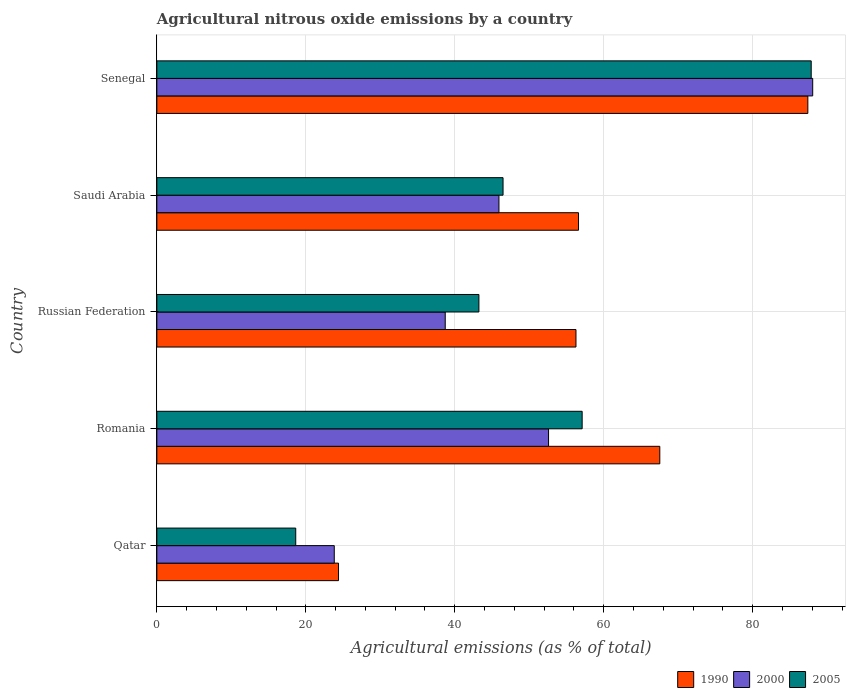How many groups of bars are there?
Offer a very short reply. 5. How many bars are there on the 4th tick from the top?
Your answer should be compact. 3. What is the label of the 2nd group of bars from the top?
Your response must be concise. Saudi Arabia. What is the amount of agricultural nitrous oxide emitted in 1990 in Senegal?
Ensure brevity in your answer.  87.4. Across all countries, what is the maximum amount of agricultural nitrous oxide emitted in 2000?
Provide a short and direct response. 88.05. Across all countries, what is the minimum amount of agricultural nitrous oxide emitted in 2000?
Provide a succinct answer. 23.82. In which country was the amount of agricultural nitrous oxide emitted in 2000 maximum?
Your response must be concise. Senegal. In which country was the amount of agricultural nitrous oxide emitted in 2005 minimum?
Keep it short and to the point. Qatar. What is the total amount of agricultural nitrous oxide emitted in 2005 in the graph?
Your answer should be compact. 253.32. What is the difference between the amount of agricultural nitrous oxide emitted in 2000 in Qatar and that in Russian Federation?
Ensure brevity in your answer.  -14.9. What is the difference between the amount of agricultural nitrous oxide emitted in 2005 in Saudi Arabia and the amount of agricultural nitrous oxide emitted in 2000 in Senegal?
Keep it short and to the point. -41.57. What is the average amount of agricultural nitrous oxide emitted in 1990 per country?
Offer a terse response. 58.44. What is the difference between the amount of agricultural nitrous oxide emitted in 2000 and amount of agricultural nitrous oxide emitted in 1990 in Qatar?
Ensure brevity in your answer.  -0.57. In how many countries, is the amount of agricultural nitrous oxide emitted in 2000 greater than 80 %?
Your answer should be compact. 1. What is the ratio of the amount of agricultural nitrous oxide emitted in 2005 in Qatar to that in Russian Federation?
Your answer should be compact. 0.43. What is the difference between the highest and the second highest amount of agricultural nitrous oxide emitted in 1990?
Provide a short and direct response. 19.88. What is the difference between the highest and the lowest amount of agricultural nitrous oxide emitted in 1990?
Ensure brevity in your answer.  63.01. What does the 2nd bar from the top in Saudi Arabia represents?
Your answer should be very brief. 2000. Is it the case that in every country, the sum of the amount of agricultural nitrous oxide emitted in 2000 and amount of agricultural nitrous oxide emitted in 2005 is greater than the amount of agricultural nitrous oxide emitted in 1990?
Provide a short and direct response. Yes. Are all the bars in the graph horizontal?
Your answer should be compact. Yes. How many countries are there in the graph?
Your answer should be compact. 5. Are the values on the major ticks of X-axis written in scientific E-notation?
Give a very brief answer. No. Does the graph contain grids?
Offer a terse response. Yes. Where does the legend appear in the graph?
Provide a succinct answer. Bottom right. What is the title of the graph?
Your answer should be compact. Agricultural nitrous oxide emissions by a country. What is the label or title of the X-axis?
Make the answer very short. Agricultural emissions (as % of total). What is the label or title of the Y-axis?
Keep it short and to the point. Country. What is the Agricultural emissions (as % of total) of 1990 in Qatar?
Your response must be concise. 24.39. What is the Agricultural emissions (as % of total) in 2000 in Qatar?
Ensure brevity in your answer.  23.82. What is the Agricultural emissions (as % of total) in 2005 in Qatar?
Make the answer very short. 18.65. What is the Agricultural emissions (as % of total) in 1990 in Romania?
Your answer should be very brief. 67.52. What is the Agricultural emissions (as % of total) of 2000 in Romania?
Keep it short and to the point. 52.59. What is the Agricultural emissions (as % of total) of 2005 in Romania?
Your answer should be compact. 57.1. What is the Agricultural emissions (as % of total) in 1990 in Russian Federation?
Give a very brief answer. 56.27. What is the Agricultural emissions (as % of total) of 2000 in Russian Federation?
Your answer should be very brief. 38.72. What is the Agricultural emissions (as % of total) of 2005 in Russian Federation?
Give a very brief answer. 43.24. What is the Agricultural emissions (as % of total) of 1990 in Saudi Arabia?
Your response must be concise. 56.61. What is the Agricultural emissions (as % of total) in 2000 in Saudi Arabia?
Keep it short and to the point. 45.93. What is the Agricultural emissions (as % of total) of 2005 in Saudi Arabia?
Your response must be concise. 46.48. What is the Agricultural emissions (as % of total) of 1990 in Senegal?
Your response must be concise. 87.4. What is the Agricultural emissions (as % of total) in 2000 in Senegal?
Make the answer very short. 88.05. What is the Agricultural emissions (as % of total) in 2005 in Senegal?
Provide a succinct answer. 87.85. Across all countries, what is the maximum Agricultural emissions (as % of total) of 1990?
Keep it short and to the point. 87.4. Across all countries, what is the maximum Agricultural emissions (as % of total) of 2000?
Keep it short and to the point. 88.05. Across all countries, what is the maximum Agricultural emissions (as % of total) in 2005?
Give a very brief answer. 87.85. Across all countries, what is the minimum Agricultural emissions (as % of total) in 1990?
Offer a terse response. 24.39. Across all countries, what is the minimum Agricultural emissions (as % of total) of 2000?
Give a very brief answer. 23.82. Across all countries, what is the minimum Agricultural emissions (as % of total) in 2005?
Provide a succinct answer. 18.65. What is the total Agricultural emissions (as % of total) in 1990 in the graph?
Offer a terse response. 292.2. What is the total Agricultural emissions (as % of total) in 2000 in the graph?
Keep it short and to the point. 249.11. What is the total Agricultural emissions (as % of total) of 2005 in the graph?
Your answer should be very brief. 253.32. What is the difference between the Agricultural emissions (as % of total) of 1990 in Qatar and that in Romania?
Provide a short and direct response. -43.13. What is the difference between the Agricultural emissions (as % of total) of 2000 in Qatar and that in Romania?
Your answer should be compact. -28.77. What is the difference between the Agricultural emissions (as % of total) of 2005 in Qatar and that in Romania?
Offer a terse response. -38.45. What is the difference between the Agricultural emissions (as % of total) in 1990 in Qatar and that in Russian Federation?
Your answer should be very brief. -31.88. What is the difference between the Agricultural emissions (as % of total) in 2000 in Qatar and that in Russian Federation?
Provide a succinct answer. -14.9. What is the difference between the Agricultural emissions (as % of total) in 2005 in Qatar and that in Russian Federation?
Make the answer very short. -24.59. What is the difference between the Agricultural emissions (as % of total) of 1990 in Qatar and that in Saudi Arabia?
Keep it short and to the point. -32.22. What is the difference between the Agricultural emissions (as % of total) in 2000 in Qatar and that in Saudi Arabia?
Ensure brevity in your answer.  -22.11. What is the difference between the Agricultural emissions (as % of total) of 2005 in Qatar and that in Saudi Arabia?
Your response must be concise. -27.83. What is the difference between the Agricultural emissions (as % of total) of 1990 in Qatar and that in Senegal?
Ensure brevity in your answer.  -63.01. What is the difference between the Agricultural emissions (as % of total) of 2000 in Qatar and that in Senegal?
Provide a short and direct response. -64.23. What is the difference between the Agricultural emissions (as % of total) in 2005 in Qatar and that in Senegal?
Provide a short and direct response. -69.2. What is the difference between the Agricultural emissions (as % of total) in 1990 in Romania and that in Russian Federation?
Offer a terse response. 11.25. What is the difference between the Agricultural emissions (as % of total) of 2000 in Romania and that in Russian Federation?
Offer a very short reply. 13.87. What is the difference between the Agricultural emissions (as % of total) of 2005 in Romania and that in Russian Federation?
Keep it short and to the point. 13.86. What is the difference between the Agricultural emissions (as % of total) in 1990 in Romania and that in Saudi Arabia?
Ensure brevity in your answer.  10.91. What is the difference between the Agricultural emissions (as % of total) in 2000 in Romania and that in Saudi Arabia?
Give a very brief answer. 6.66. What is the difference between the Agricultural emissions (as % of total) of 2005 in Romania and that in Saudi Arabia?
Give a very brief answer. 10.62. What is the difference between the Agricultural emissions (as % of total) of 1990 in Romania and that in Senegal?
Provide a short and direct response. -19.88. What is the difference between the Agricultural emissions (as % of total) in 2000 in Romania and that in Senegal?
Provide a short and direct response. -35.47. What is the difference between the Agricultural emissions (as % of total) in 2005 in Romania and that in Senegal?
Offer a very short reply. -30.75. What is the difference between the Agricultural emissions (as % of total) in 1990 in Russian Federation and that in Saudi Arabia?
Provide a short and direct response. -0.34. What is the difference between the Agricultural emissions (as % of total) of 2000 in Russian Federation and that in Saudi Arabia?
Offer a very short reply. -7.21. What is the difference between the Agricultural emissions (as % of total) of 2005 in Russian Federation and that in Saudi Arabia?
Offer a terse response. -3.24. What is the difference between the Agricultural emissions (as % of total) of 1990 in Russian Federation and that in Senegal?
Keep it short and to the point. -31.13. What is the difference between the Agricultural emissions (as % of total) of 2000 in Russian Federation and that in Senegal?
Offer a very short reply. -49.34. What is the difference between the Agricultural emissions (as % of total) in 2005 in Russian Federation and that in Senegal?
Make the answer very short. -44.61. What is the difference between the Agricultural emissions (as % of total) in 1990 in Saudi Arabia and that in Senegal?
Your response must be concise. -30.79. What is the difference between the Agricultural emissions (as % of total) in 2000 in Saudi Arabia and that in Senegal?
Ensure brevity in your answer.  -42.12. What is the difference between the Agricultural emissions (as % of total) of 2005 in Saudi Arabia and that in Senegal?
Keep it short and to the point. -41.37. What is the difference between the Agricultural emissions (as % of total) in 1990 in Qatar and the Agricultural emissions (as % of total) in 2000 in Romania?
Provide a succinct answer. -28.2. What is the difference between the Agricultural emissions (as % of total) in 1990 in Qatar and the Agricultural emissions (as % of total) in 2005 in Romania?
Your response must be concise. -32.71. What is the difference between the Agricultural emissions (as % of total) of 2000 in Qatar and the Agricultural emissions (as % of total) of 2005 in Romania?
Your response must be concise. -33.28. What is the difference between the Agricultural emissions (as % of total) in 1990 in Qatar and the Agricultural emissions (as % of total) in 2000 in Russian Federation?
Make the answer very short. -14.33. What is the difference between the Agricultural emissions (as % of total) of 1990 in Qatar and the Agricultural emissions (as % of total) of 2005 in Russian Federation?
Make the answer very short. -18.85. What is the difference between the Agricultural emissions (as % of total) in 2000 in Qatar and the Agricultural emissions (as % of total) in 2005 in Russian Federation?
Ensure brevity in your answer.  -19.42. What is the difference between the Agricultural emissions (as % of total) in 1990 in Qatar and the Agricultural emissions (as % of total) in 2000 in Saudi Arabia?
Offer a terse response. -21.54. What is the difference between the Agricultural emissions (as % of total) of 1990 in Qatar and the Agricultural emissions (as % of total) of 2005 in Saudi Arabia?
Make the answer very short. -22.09. What is the difference between the Agricultural emissions (as % of total) in 2000 in Qatar and the Agricultural emissions (as % of total) in 2005 in Saudi Arabia?
Make the answer very short. -22.66. What is the difference between the Agricultural emissions (as % of total) of 1990 in Qatar and the Agricultural emissions (as % of total) of 2000 in Senegal?
Ensure brevity in your answer.  -63.66. What is the difference between the Agricultural emissions (as % of total) in 1990 in Qatar and the Agricultural emissions (as % of total) in 2005 in Senegal?
Make the answer very short. -63.46. What is the difference between the Agricultural emissions (as % of total) of 2000 in Qatar and the Agricultural emissions (as % of total) of 2005 in Senegal?
Offer a very short reply. -64.03. What is the difference between the Agricultural emissions (as % of total) of 1990 in Romania and the Agricultural emissions (as % of total) of 2000 in Russian Federation?
Provide a short and direct response. 28.81. What is the difference between the Agricultural emissions (as % of total) of 1990 in Romania and the Agricultural emissions (as % of total) of 2005 in Russian Federation?
Provide a succinct answer. 24.28. What is the difference between the Agricultural emissions (as % of total) in 2000 in Romania and the Agricultural emissions (as % of total) in 2005 in Russian Federation?
Make the answer very short. 9.35. What is the difference between the Agricultural emissions (as % of total) in 1990 in Romania and the Agricultural emissions (as % of total) in 2000 in Saudi Arabia?
Ensure brevity in your answer.  21.59. What is the difference between the Agricultural emissions (as % of total) in 1990 in Romania and the Agricultural emissions (as % of total) in 2005 in Saudi Arabia?
Your answer should be very brief. 21.04. What is the difference between the Agricultural emissions (as % of total) of 2000 in Romania and the Agricultural emissions (as % of total) of 2005 in Saudi Arabia?
Your answer should be very brief. 6.11. What is the difference between the Agricultural emissions (as % of total) in 1990 in Romania and the Agricultural emissions (as % of total) in 2000 in Senegal?
Your response must be concise. -20.53. What is the difference between the Agricultural emissions (as % of total) of 1990 in Romania and the Agricultural emissions (as % of total) of 2005 in Senegal?
Offer a terse response. -20.33. What is the difference between the Agricultural emissions (as % of total) of 2000 in Romania and the Agricultural emissions (as % of total) of 2005 in Senegal?
Make the answer very short. -35.26. What is the difference between the Agricultural emissions (as % of total) of 1990 in Russian Federation and the Agricultural emissions (as % of total) of 2000 in Saudi Arabia?
Provide a succinct answer. 10.34. What is the difference between the Agricultural emissions (as % of total) of 1990 in Russian Federation and the Agricultural emissions (as % of total) of 2005 in Saudi Arabia?
Your response must be concise. 9.79. What is the difference between the Agricultural emissions (as % of total) in 2000 in Russian Federation and the Agricultural emissions (as % of total) in 2005 in Saudi Arabia?
Provide a short and direct response. -7.76. What is the difference between the Agricultural emissions (as % of total) in 1990 in Russian Federation and the Agricultural emissions (as % of total) in 2000 in Senegal?
Make the answer very short. -31.78. What is the difference between the Agricultural emissions (as % of total) of 1990 in Russian Federation and the Agricultural emissions (as % of total) of 2005 in Senegal?
Offer a terse response. -31.58. What is the difference between the Agricultural emissions (as % of total) in 2000 in Russian Federation and the Agricultural emissions (as % of total) in 2005 in Senegal?
Ensure brevity in your answer.  -49.13. What is the difference between the Agricultural emissions (as % of total) in 1990 in Saudi Arabia and the Agricultural emissions (as % of total) in 2000 in Senegal?
Provide a succinct answer. -31.44. What is the difference between the Agricultural emissions (as % of total) in 1990 in Saudi Arabia and the Agricultural emissions (as % of total) in 2005 in Senegal?
Make the answer very short. -31.24. What is the difference between the Agricultural emissions (as % of total) of 2000 in Saudi Arabia and the Agricultural emissions (as % of total) of 2005 in Senegal?
Your answer should be compact. -41.92. What is the average Agricultural emissions (as % of total) of 1990 per country?
Your response must be concise. 58.44. What is the average Agricultural emissions (as % of total) of 2000 per country?
Offer a terse response. 49.82. What is the average Agricultural emissions (as % of total) of 2005 per country?
Provide a short and direct response. 50.66. What is the difference between the Agricultural emissions (as % of total) in 1990 and Agricultural emissions (as % of total) in 2000 in Qatar?
Your answer should be very brief. 0.57. What is the difference between the Agricultural emissions (as % of total) of 1990 and Agricultural emissions (as % of total) of 2005 in Qatar?
Give a very brief answer. 5.74. What is the difference between the Agricultural emissions (as % of total) of 2000 and Agricultural emissions (as % of total) of 2005 in Qatar?
Your response must be concise. 5.17. What is the difference between the Agricultural emissions (as % of total) of 1990 and Agricultural emissions (as % of total) of 2000 in Romania?
Provide a succinct answer. 14.94. What is the difference between the Agricultural emissions (as % of total) in 1990 and Agricultural emissions (as % of total) in 2005 in Romania?
Your answer should be very brief. 10.42. What is the difference between the Agricultural emissions (as % of total) of 2000 and Agricultural emissions (as % of total) of 2005 in Romania?
Keep it short and to the point. -4.51. What is the difference between the Agricultural emissions (as % of total) of 1990 and Agricultural emissions (as % of total) of 2000 in Russian Federation?
Keep it short and to the point. 17.55. What is the difference between the Agricultural emissions (as % of total) of 1990 and Agricultural emissions (as % of total) of 2005 in Russian Federation?
Provide a succinct answer. 13.03. What is the difference between the Agricultural emissions (as % of total) in 2000 and Agricultural emissions (as % of total) in 2005 in Russian Federation?
Keep it short and to the point. -4.52. What is the difference between the Agricultural emissions (as % of total) in 1990 and Agricultural emissions (as % of total) in 2000 in Saudi Arabia?
Provide a succinct answer. 10.68. What is the difference between the Agricultural emissions (as % of total) in 1990 and Agricultural emissions (as % of total) in 2005 in Saudi Arabia?
Provide a succinct answer. 10.13. What is the difference between the Agricultural emissions (as % of total) in 2000 and Agricultural emissions (as % of total) in 2005 in Saudi Arabia?
Keep it short and to the point. -0.55. What is the difference between the Agricultural emissions (as % of total) of 1990 and Agricultural emissions (as % of total) of 2000 in Senegal?
Your answer should be very brief. -0.65. What is the difference between the Agricultural emissions (as % of total) of 1990 and Agricultural emissions (as % of total) of 2005 in Senegal?
Provide a succinct answer. -0.45. What is the difference between the Agricultural emissions (as % of total) in 2000 and Agricultural emissions (as % of total) in 2005 in Senegal?
Give a very brief answer. 0.2. What is the ratio of the Agricultural emissions (as % of total) of 1990 in Qatar to that in Romania?
Your answer should be compact. 0.36. What is the ratio of the Agricultural emissions (as % of total) in 2000 in Qatar to that in Romania?
Ensure brevity in your answer.  0.45. What is the ratio of the Agricultural emissions (as % of total) in 2005 in Qatar to that in Romania?
Ensure brevity in your answer.  0.33. What is the ratio of the Agricultural emissions (as % of total) of 1990 in Qatar to that in Russian Federation?
Provide a short and direct response. 0.43. What is the ratio of the Agricultural emissions (as % of total) of 2000 in Qatar to that in Russian Federation?
Offer a terse response. 0.62. What is the ratio of the Agricultural emissions (as % of total) in 2005 in Qatar to that in Russian Federation?
Offer a very short reply. 0.43. What is the ratio of the Agricultural emissions (as % of total) in 1990 in Qatar to that in Saudi Arabia?
Ensure brevity in your answer.  0.43. What is the ratio of the Agricultural emissions (as % of total) of 2000 in Qatar to that in Saudi Arabia?
Offer a very short reply. 0.52. What is the ratio of the Agricultural emissions (as % of total) in 2005 in Qatar to that in Saudi Arabia?
Offer a very short reply. 0.4. What is the ratio of the Agricultural emissions (as % of total) in 1990 in Qatar to that in Senegal?
Provide a succinct answer. 0.28. What is the ratio of the Agricultural emissions (as % of total) in 2000 in Qatar to that in Senegal?
Ensure brevity in your answer.  0.27. What is the ratio of the Agricultural emissions (as % of total) in 2005 in Qatar to that in Senegal?
Provide a succinct answer. 0.21. What is the ratio of the Agricultural emissions (as % of total) in 1990 in Romania to that in Russian Federation?
Offer a very short reply. 1.2. What is the ratio of the Agricultural emissions (as % of total) of 2000 in Romania to that in Russian Federation?
Offer a terse response. 1.36. What is the ratio of the Agricultural emissions (as % of total) of 2005 in Romania to that in Russian Federation?
Provide a succinct answer. 1.32. What is the ratio of the Agricultural emissions (as % of total) of 1990 in Romania to that in Saudi Arabia?
Your response must be concise. 1.19. What is the ratio of the Agricultural emissions (as % of total) of 2000 in Romania to that in Saudi Arabia?
Your answer should be compact. 1.15. What is the ratio of the Agricultural emissions (as % of total) in 2005 in Romania to that in Saudi Arabia?
Offer a very short reply. 1.23. What is the ratio of the Agricultural emissions (as % of total) in 1990 in Romania to that in Senegal?
Your answer should be compact. 0.77. What is the ratio of the Agricultural emissions (as % of total) of 2000 in Romania to that in Senegal?
Keep it short and to the point. 0.6. What is the ratio of the Agricultural emissions (as % of total) in 2005 in Romania to that in Senegal?
Offer a very short reply. 0.65. What is the ratio of the Agricultural emissions (as % of total) in 2000 in Russian Federation to that in Saudi Arabia?
Offer a terse response. 0.84. What is the ratio of the Agricultural emissions (as % of total) of 2005 in Russian Federation to that in Saudi Arabia?
Ensure brevity in your answer.  0.93. What is the ratio of the Agricultural emissions (as % of total) of 1990 in Russian Federation to that in Senegal?
Provide a short and direct response. 0.64. What is the ratio of the Agricultural emissions (as % of total) of 2000 in Russian Federation to that in Senegal?
Offer a terse response. 0.44. What is the ratio of the Agricultural emissions (as % of total) in 2005 in Russian Federation to that in Senegal?
Provide a short and direct response. 0.49. What is the ratio of the Agricultural emissions (as % of total) in 1990 in Saudi Arabia to that in Senegal?
Your answer should be very brief. 0.65. What is the ratio of the Agricultural emissions (as % of total) in 2000 in Saudi Arabia to that in Senegal?
Your answer should be very brief. 0.52. What is the ratio of the Agricultural emissions (as % of total) of 2005 in Saudi Arabia to that in Senegal?
Keep it short and to the point. 0.53. What is the difference between the highest and the second highest Agricultural emissions (as % of total) in 1990?
Your response must be concise. 19.88. What is the difference between the highest and the second highest Agricultural emissions (as % of total) in 2000?
Your response must be concise. 35.47. What is the difference between the highest and the second highest Agricultural emissions (as % of total) of 2005?
Make the answer very short. 30.75. What is the difference between the highest and the lowest Agricultural emissions (as % of total) in 1990?
Keep it short and to the point. 63.01. What is the difference between the highest and the lowest Agricultural emissions (as % of total) of 2000?
Provide a short and direct response. 64.23. What is the difference between the highest and the lowest Agricultural emissions (as % of total) in 2005?
Make the answer very short. 69.2. 